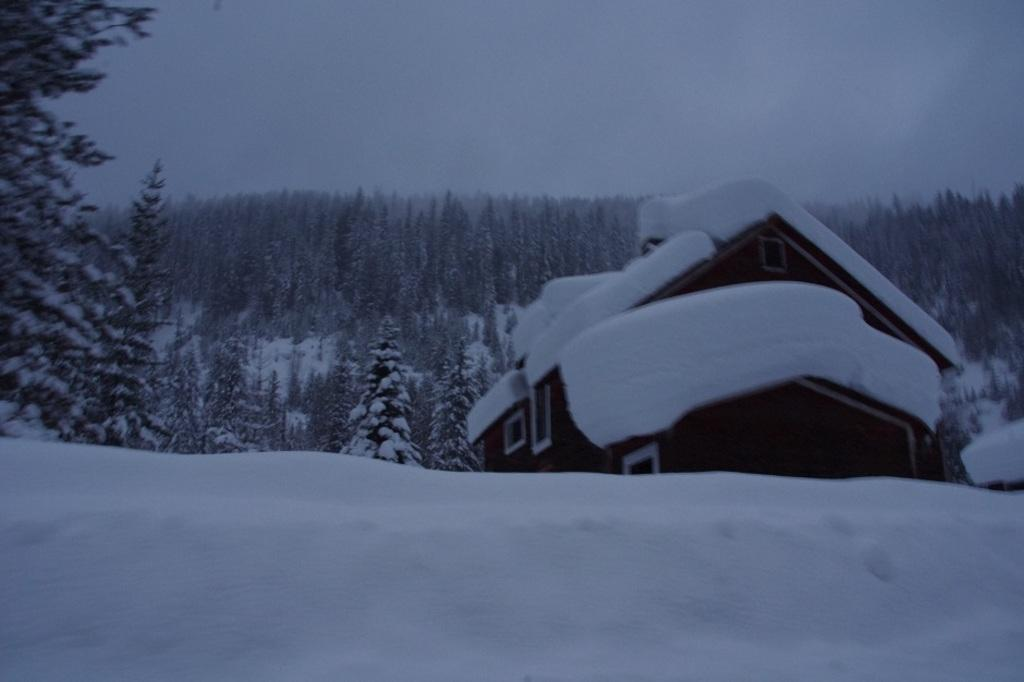What is the main feature of the landscape in the image? There is snow in the image. What type of structure is present in the image? There is a house in the image. What can be seen in the distance in the image? There are trees in the background of the image. How would you describe the weather based on the image? The sky is clear in the background of the image, suggesting good weather. What type of lock can be seen on the glass door of the house in the image? There is no glass door or lock visible in the image; it only shows snow, a house, trees, and a clear sky. 